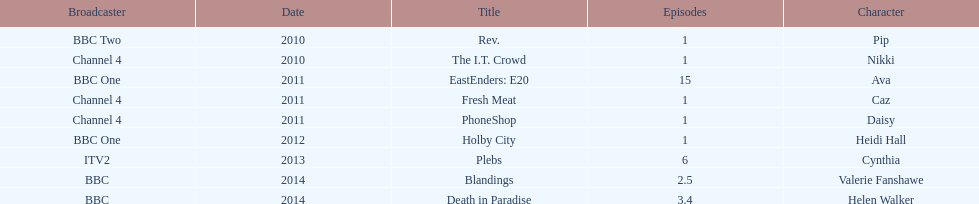What is the only role she played with broadcaster itv2? Cynthia. 